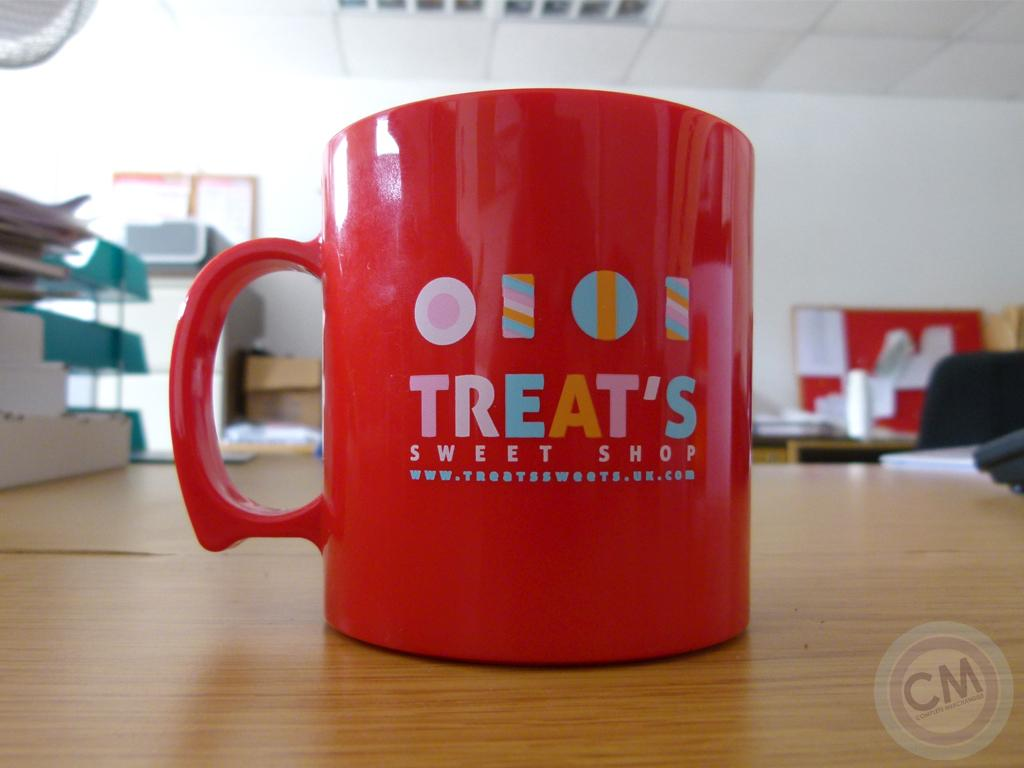<image>
Relay a brief, clear account of the picture shown. A red mug from Treat's Sweet Shop sits alone on a large wooden topped table. 